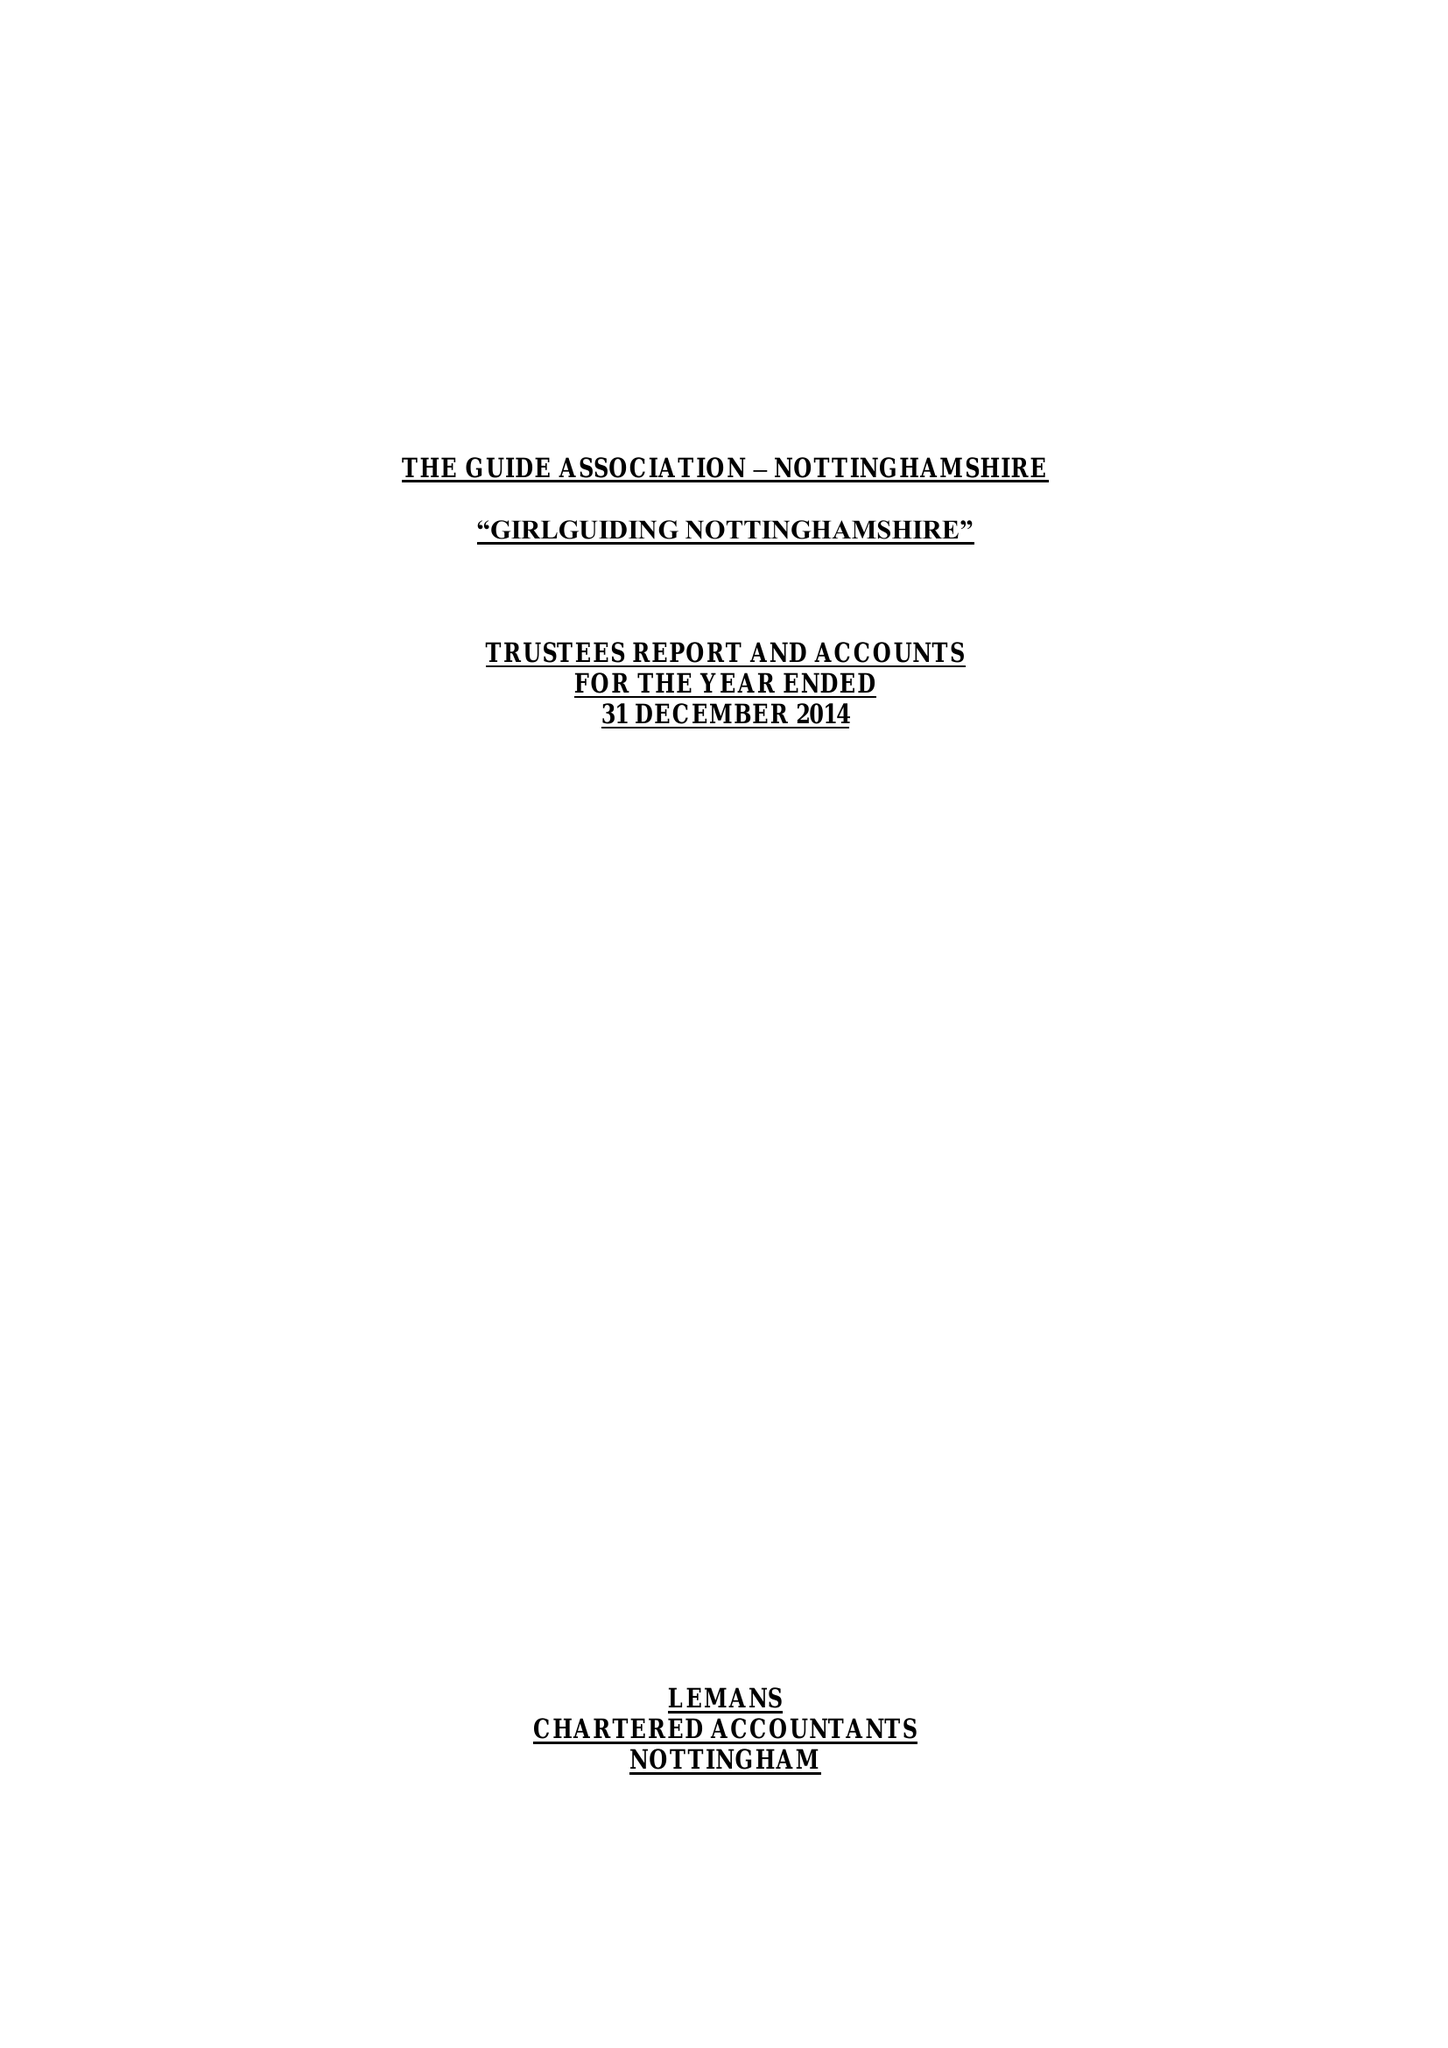What is the value for the spending_annually_in_british_pounds?
Answer the question using a single word or phrase. 319495.00 